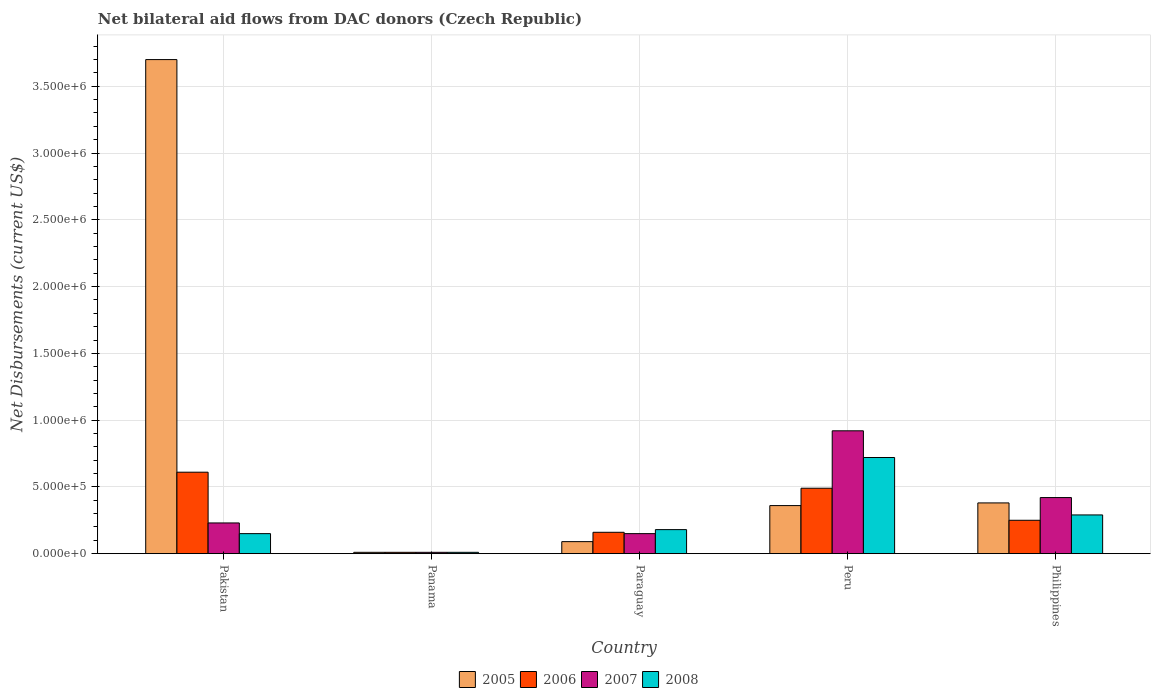Are the number of bars per tick equal to the number of legend labels?
Your answer should be very brief. Yes. How many bars are there on the 4th tick from the right?
Give a very brief answer. 4. What is the label of the 3rd group of bars from the left?
Your answer should be compact. Paraguay. In how many cases, is the number of bars for a given country not equal to the number of legend labels?
Provide a succinct answer. 0. Across all countries, what is the minimum net bilateral aid flows in 2008?
Provide a short and direct response. 10000. In which country was the net bilateral aid flows in 2007 minimum?
Your answer should be very brief. Panama. What is the total net bilateral aid flows in 2006 in the graph?
Give a very brief answer. 1.52e+06. What is the difference between the net bilateral aid flows in 2005 in Pakistan and that in Peru?
Keep it short and to the point. 3.34e+06. What is the difference between the net bilateral aid flows in 2006 in Philippines and the net bilateral aid flows in 2005 in Pakistan?
Make the answer very short. -3.45e+06. What is the average net bilateral aid flows in 2006 per country?
Your answer should be compact. 3.04e+05. What is the difference between the net bilateral aid flows of/in 2008 and net bilateral aid flows of/in 2006 in Pakistan?
Keep it short and to the point. -4.60e+05. In how many countries, is the net bilateral aid flows in 2006 greater than 1700000 US$?
Your answer should be compact. 0. What is the ratio of the net bilateral aid flows in 2006 in Panama to that in Philippines?
Keep it short and to the point. 0.04. What is the difference between the highest and the second highest net bilateral aid flows in 2007?
Give a very brief answer. 6.90e+05. What is the difference between the highest and the lowest net bilateral aid flows in 2007?
Offer a very short reply. 9.10e+05. Is the sum of the net bilateral aid flows in 2006 in Pakistan and Philippines greater than the maximum net bilateral aid flows in 2007 across all countries?
Keep it short and to the point. No. Is it the case that in every country, the sum of the net bilateral aid flows in 2006 and net bilateral aid flows in 2008 is greater than the sum of net bilateral aid flows in 2005 and net bilateral aid flows in 2007?
Provide a short and direct response. No. What does the 3rd bar from the left in Paraguay represents?
Provide a short and direct response. 2007. How many bars are there?
Give a very brief answer. 20. Are all the bars in the graph horizontal?
Give a very brief answer. No. Are the values on the major ticks of Y-axis written in scientific E-notation?
Your answer should be very brief. Yes. How many legend labels are there?
Your answer should be very brief. 4. How are the legend labels stacked?
Give a very brief answer. Horizontal. What is the title of the graph?
Provide a succinct answer. Net bilateral aid flows from DAC donors (Czech Republic). Does "1980" appear as one of the legend labels in the graph?
Offer a very short reply. No. What is the label or title of the X-axis?
Offer a terse response. Country. What is the label or title of the Y-axis?
Your answer should be compact. Net Disbursements (current US$). What is the Net Disbursements (current US$) of 2005 in Pakistan?
Give a very brief answer. 3.70e+06. What is the Net Disbursements (current US$) in 2005 in Panama?
Ensure brevity in your answer.  10000. What is the Net Disbursements (current US$) in 2006 in Panama?
Your answer should be compact. 10000. What is the Net Disbursements (current US$) in 2007 in Panama?
Give a very brief answer. 10000. What is the Net Disbursements (current US$) of 2005 in Paraguay?
Ensure brevity in your answer.  9.00e+04. What is the Net Disbursements (current US$) in 2007 in Paraguay?
Your response must be concise. 1.50e+05. What is the Net Disbursements (current US$) in 2005 in Peru?
Ensure brevity in your answer.  3.60e+05. What is the Net Disbursements (current US$) in 2006 in Peru?
Keep it short and to the point. 4.90e+05. What is the Net Disbursements (current US$) of 2007 in Peru?
Provide a succinct answer. 9.20e+05. What is the Net Disbursements (current US$) in 2008 in Peru?
Offer a terse response. 7.20e+05. What is the Net Disbursements (current US$) of 2005 in Philippines?
Offer a terse response. 3.80e+05. What is the Net Disbursements (current US$) of 2007 in Philippines?
Ensure brevity in your answer.  4.20e+05. Across all countries, what is the maximum Net Disbursements (current US$) in 2005?
Your response must be concise. 3.70e+06. Across all countries, what is the maximum Net Disbursements (current US$) of 2006?
Make the answer very short. 6.10e+05. Across all countries, what is the maximum Net Disbursements (current US$) in 2007?
Your answer should be compact. 9.20e+05. Across all countries, what is the maximum Net Disbursements (current US$) of 2008?
Your answer should be compact. 7.20e+05. What is the total Net Disbursements (current US$) of 2005 in the graph?
Offer a very short reply. 4.54e+06. What is the total Net Disbursements (current US$) in 2006 in the graph?
Provide a succinct answer. 1.52e+06. What is the total Net Disbursements (current US$) in 2007 in the graph?
Your answer should be compact. 1.73e+06. What is the total Net Disbursements (current US$) in 2008 in the graph?
Give a very brief answer. 1.35e+06. What is the difference between the Net Disbursements (current US$) of 2005 in Pakistan and that in Panama?
Your response must be concise. 3.69e+06. What is the difference between the Net Disbursements (current US$) in 2007 in Pakistan and that in Panama?
Your answer should be compact. 2.20e+05. What is the difference between the Net Disbursements (current US$) in 2008 in Pakistan and that in Panama?
Provide a succinct answer. 1.40e+05. What is the difference between the Net Disbursements (current US$) of 2005 in Pakistan and that in Paraguay?
Keep it short and to the point. 3.61e+06. What is the difference between the Net Disbursements (current US$) in 2006 in Pakistan and that in Paraguay?
Make the answer very short. 4.50e+05. What is the difference between the Net Disbursements (current US$) of 2008 in Pakistan and that in Paraguay?
Give a very brief answer. -3.00e+04. What is the difference between the Net Disbursements (current US$) in 2005 in Pakistan and that in Peru?
Offer a terse response. 3.34e+06. What is the difference between the Net Disbursements (current US$) in 2006 in Pakistan and that in Peru?
Your response must be concise. 1.20e+05. What is the difference between the Net Disbursements (current US$) in 2007 in Pakistan and that in Peru?
Your answer should be very brief. -6.90e+05. What is the difference between the Net Disbursements (current US$) of 2008 in Pakistan and that in Peru?
Offer a very short reply. -5.70e+05. What is the difference between the Net Disbursements (current US$) in 2005 in Pakistan and that in Philippines?
Provide a short and direct response. 3.32e+06. What is the difference between the Net Disbursements (current US$) of 2006 in Pakistan and that in Philippines?
Provide a succinct answer. 3.60e+05. What is the difference between the Net Disbursements (current US$) in 2007 in Pakistan and that in Philippines?
Your answer should be very brief. -1.90e+05. What is the difference between the Net Disbursements (current US$) of 2008 in Pakistan and that in Philippines?
Your answer should be very brief. -1.40e+05. What is the difference between the Net Disbursements (current US$) in 2005 in Panama and that in Paraguay?
Your answer should be very brief. -8.00e+04. What is the difference between the Net Disbursements (current US$) in 2006 in Panama and that in Paraguay?
Keep it short and to the point. -1.50e+05. What is the difference between the Net Disbursements (current US$) in 2005 in Panama and that in Peru?
Provide a short and direct response. -3.50e+05. What is the difference between the Net Disbursements (current US$) in 2006 in Panama and that in Peru?
Keep it short and to the point. -4.80e+05. What is the difference between the Net Disbursements (current US$) of 2007 in Panama and that in Peru?
Ensure brevity in your answer.  -9.10e+05. What is the difference between the Net Disbursements (current US$) in 2008 in Panama and that in Peru?
Offer a terse response. -7.10e+05. What is the difference between the Net Disbursements (current US$) in 2005 in Panama and that in Philippines?
Offer a terse response. -3.70e+05. What is the difference between the Net Disbursements (current US$) in 2007 in Panama and that in Philippines?
Offer a terse response. -4.10e+05. What is the difference between the Net Disbursements (current US$) in 2008 in Panama and that in Philippines?
Ensure brevity in your answer.  -2.80e+05. What is the difference between the Net Disbursements (current US$) of 2006 in Paraguay and that in Peru?
Provide a short and direct response. -3.30e+05. What is the difference between the Net Disbursements (current US$) in 2007 in Paraguay and that in Peru?
Your answer should be very brief. -7.70e+05. What is the difference between the Net Disbursements (current US$) in 2008 in Paraguay and that in Peru?
Provide a succinct answer. -5.40e+05. What is the difference between the Net Disbursements (current US$) of 2006 in Paraguay and that in Philippines?
Offer a terse response. -9.00e+04. What is the difference between the Net Disbursements (current US$) of 2007 in Paraguay and that in Philippines?
Ensure brevity in your answer.  -2.70e+05. What is the difference between the Net Disbursements (current US$) of 2006 in Peru and that in Philippines?
Offer a very short reply. 2.40e+05. What is the difference between the Net Disbursements (current US$) in 2005 in Pakistan and the Net Disbursements (current US$) in 2006 in Panama?
Your answer should be very brief. 3.69e+06. What is the difference between the Net Disbursements (current US$) in 2005 in Pakistan and the Net Disbursements (current US$) in 2007 in Panama?
Offer a terse response. 3.69e+06. What is the difference between the Net Disbursements (current US$) in 2005 in Pakistan and the Net Disbursements (current US$) in 2008 in Panama?
Keep it short and to the point. 3.69e+06. What is the difference between the Net Disbursements (current US$) in 2006 in Pakistan and the Net Disbursements (current US$) in 2007 in Panama?
Keep it short and to the point. 6.00e+05. What is the difference between the Net Disbursements (current US$) of 2006 in Pakistan and the Net Disbursements (current US$) of 2008 in Panama?
Provide a short and direct response. 6.00e+05. What is the difference between the Net Disbursements (current US$) in 2007 in Pakistan and the Net Disbursements (current US$) in 2008 in Panama?
Keep it short and to the point. 2.20e+05. What is the difference between the Net Disbursements (current US$) of 2005 in Pakistan and the Net Disbursements (current US$) of 2006 in Paraguay?
Make the answer very short. 3.54e+06. What is the difference between the Net Disbursements (current US$) of 2005 in Pakistan and the Net Disbursements (current US$) of 2007 in Paraguay?
Provide a succinct answer. 3.55e+06. What is the difference between the Net Disbursements (current US$) in 2005 in Pakistan and the Net Disbursements (current US$) in 2008 in Paraguay?
Provide a short and direct response. 3.52e+06. What is the difference between the Net Disbursements (current US$) of 2006 in Pakistan and the Net Disbursements (current US$) of 2007 in Paraguay?
Ensure brevity in your answer.  4.60e+05. What is the difference between the Net Disbursements (current US$) of 2006 in Pakistan and the Net Disbursements (current US$) of 2008 in Paraguay?
Make the answer very short. 4.30e+05. What is the difference between the Net Disbursements (current US$) in 2007 in Pakistan and the Net Disbursements (current US$) in 2008 in Paraguay?
Your answer should be very brief. 5.00e+04. What is the difference between the Net Disbursements (current US$) of 2005 in Pakistan and the Net Disbursements (current US$) of 2006 in Peru?
Make the answer very short. 3.21e+06. What is the difference between the Net Disbursements (current US$) of 2005 in Pakistan and the Net Disbursements (current US$) of 2007 in Peru?
Your answer should be compact. 2.78e+06. What is the difference between the Net Disbursements (current US$) of 2005 in Pakistan and the Net Disbursements (current US$) of 2008 in Peru?
Give a very brief answer. 2.98e+06. What is the difference between the Net Disbursements (current US$) in 2006 in Pakistan and the Net Disbursements (current US$) in 2007 in Peru?
Your answer should be compact. -3.10e+05. What is the difference between the Net Disbursements (current US$) in 2007 in Pakistan and the Net Disbursements (current US$) in 2008 in Peru?
Your response must be concise. -4.90e+05. What is the difference between the Net Disbursements (current US$) in 2005 in Pakistan and the Net Disbursements (current US$) in 2006 in Philippines?
Give a very brief answer. 3.45e+06. What is the difference between the Net Disbursements (current US$) in 2005 in Pakistan and the Net Disbursements (current US$) in 2007 in Philippines?
Offer a very short reply. 3.28e+06. What is the difference between the Net Disbursements (current US$) of 2005 in Pakistan and the Net Disbursements (current US$) of 2008 in Philippines?
Ensure brevity in your answer.  3.41e+06. What is the difference between the Net Disbursements (current US$) in 2006 in Pakistan and the Net Disbursements (current US$) in 2007 in Philippines?
Provide a short and direct response. 1.90e+05. What is the difference between the Net Disbursements (current US$) of 2006 in Pakistan and the Net Disbursements (current US$) of 2008 in Philippines?
Provide a short and direct response. 3.20e+05. What is the difference between the Net Disbursements (current US$) of 2007 in Pakistan and the Net Disbursements (current US$) of 2008 in Philippines?
Your answer should be very brief. -6.00e+04. What is the difference between the Net Disbursements (current US$) in 2006 in Panama and the Net Disbursements (current US$) in 2007 in Paraguay?
Your answer should be compact. -1.40e+05. What is the difference between the Net Disbursements (current US$) of 2007 in Panama and the Net Disbursements (current US$) of 2008 in Paraguay?
Ensure brevity in your answer.  -1.70e+05. What is the difference between the Net Disbursements (current US$) in 2005 in Panama and the Net Disbursements (current US$) in 2006 in Peru?
Offer a very short reply. -4.80e+05. What is the difference between the Net Disbursements (current US$) of 2005 in Panama and the Net Disbursements (current US$) of 2007 in Peru?
Keep it short and to the point. -9.10e+05. What is the difference between the Net Disbursements (current US$) of 2005 in Panama and the Net Disbursements (current US$) of 2008 in Peru?
Your answer should be compact. -7.10e+05. What is the difference between the Net Disbursements (current US$) of 2006 in Panama and the Net Disbursements (current US$) of 2007 in Peru?
Keep it short and to the point. -9.10e+05. What is the difference between the Net Disbursements (current US$) of 2006 in Panama and the Net Disbursements (current US$) of 2008 in Peru?
Your response must be concise. -7.10e+05. What is the difference between the Net Disbursements (current US$) of 2007 in Panama and the Net Disbursements (current US$) of 2008 in Peru?
Your response must be concise. -7.10e+05. What is the difference between the Net Disbursements (current US$) in 2005 in Panama and the Net Disbursements (current US$) in 2006 in Philippines?
Keep it short and to the point. -2.40e+05. What is the difference between the Net Disbursements (current US$) in 2005 in Panama and the Net Disbursements (current US$) in 2007 in Philippines?
Your answer should be compact. -4.10e+05. What is the difference between the Net Disbursements (current US$) of 2005 in Panama and the Net Disbursements (current US$) of 2008 in Philippines?
Your answer should be very brief. -2.80e+05. What is the difference between the Net Disbursements (current US$) of 2006 in Panama and the Net Disbursements (current US$) of 2007 in Philippines?
Your response must be concise. -4.10e+05. What is the difference between the Net Disbursements (current US$) of 2006 in Panama and the Net Disbursements (current US$) of 2008 in Philippines?
Your answer should be very brief. -2.80e+05. What is the difference between the Net Disbursements (current US$) in 2007 in Panama and the Net Disbursements (current US$) in 2008 in Philippines?
Your response must be concise. -2.80e+05. What is the difference between the Net Disbursements (current US$) in 2005 in Paraguay and the Net Disbursements (current US$) in 2006 in Peru?
Keep it short and to the point. -4.00e+05. What is the difference between the Net Disbursements (current US$) of 2005 in Paraguay and the Net Disbursements (current US$) of 2007 in Peru?
Keep it short and to the point. -8.30e+05. What is the difference between the Net Disbursements (current US$) of 2005 in Paraguay and the Net Disbursements (current US$) of 2008 in Peru?
Ensure brevity in your answer.  -6.30e+05. What is the difference between the Net Disbursements (current US$) in 2006 in Paraguay and the Net Disbursements (current US$) in 2007 in Peru?
Keep it short and to the point. -7.60e+05. What is the difference between the Net Disbursements (current US$) of 2006 in Paraguay and the Net Disbursements (current US$) of 2008 in Peru?
Your answer should be very brief. -5.60e+05. What is the difference between the Net Disbursements (current US$) of 2007 in Paraguay and the Net Disbursements (current US$) of 2008 in Peru?
Provide a succinct answer. -5.70e+05. What is the difference between the Net Disbursements (current US$) in 2005 in Paraguay and the Net Disbursements (current US$) in 2007 in Philippines?
Give a very brief answer. -3.30e+05. What is the difference between the Net Disbursements (current US$) in 2006 in Paraguay and the Net Disbursements (current US$) in 2007 in Philippines?
Offer a very short reply. -2.60e+05. What is the difference between the Net Disbursements (current US$) in 2007 in Paraguay and the Net Disbursements (current US$) in 2008 in Philippines?
Your response must be concise. -1.40e+05. What is the difference between the Net Disbursements (current US$) of 2007 in Peru and the Net Disbursements (current US$) of 2008 in Philippines?
Keep it short and to the point. 6.30e+05. What is the average Net Disbursements (current US$) of 2005 per country?
Provide a succinct answer. 9.08e+05. What is the average Net Disbursements (current US$) of 2006 per country?
Provide a succinct answer. 3.04e+05. What is the average Net Disbursements (current US$) in 2007 per country?
Give a very brief answer. 3.46e+05. What is the difference between the Net Disbursements (current US$) of 2005 and Net Disbursements (current US$) of 2006 in Pakistan?
Offer a terse response. 3.09e+06. What is the difference between the Net Disbursements (current US$) in 2005 and Net Disbursements (current US$) in 2007 in Pakistan?
Offer a terse response. 3.47e+06. What is the difference between the Net Disbursements (current US$) of 2005 and Net Disbursements (current US$) of 2008 in Pakistan?
Ensure brevity in your answer.  3.55e+06. What is the difference between the Net Disbursements (current US$) in 2007 and Net Disbursements (current US$) in 2008 in Pakistan?
Offer a terse response. 8.00e+04. What is the difference between the Net Disbursements (current US$) in 2005 and Net Disbursements (current US$) in 2007 in Panama?
Give a very brief answer. 0. What is the difference between the Net Disbursements (current US$) in 2005 and Net Disbursements (current US$) in 2008 in Panama?
Ensure brevity in your answer.  0. What is the difference between the Net Disbursements (current US$) of 2005 and Net Disbursements (current US$) of 2007 in Paraguay?
Your response must be concise. -6.00e+04. What is the difference between the Net Disbursements (current US$) in 2007 and Net Disbursements (current US$) in 2008 in Paraguay?
Your answer should be compact. -3.00e+04. What is the difference between the Net Disbursements (current US$) in 2005 and Net Disbursements (current US$) in 2007 in Peru?
Provide a short and direct response. -5.60e+05. What is the difference between the Net Disbursements (current US$) of 2005 and Net Disbursements (current US$) of 2008 in Peru?
Your response must be concise. -3.60e+05. What is the difference between the Net Disbursements (current US$) of 2006 and Net Disbursements (current US$) of 2007 in Peru?
Make the answer very short. -4.30e+05. What is the difference between the Net Disbursements (current US$) in 2006 and Net Disbursements (current US$) in 2008 in Peru?
Make the answer very short. -2.30e+05. What is the difference between the Net Disbursements (current US$) in 2005 and Net Disbursements (current US$) in 2006 in Philippines?
Your answer should be very brief. 1.30e+05. What is the difference between the Net Disbursements (current US$) in 2006 and Net Disbursements (current US$) in 2007 in Philippines?
Make the answer very short. -1.70e+05. What is the difference between the Net Disbursements (current US$) of 2007 and Net Disbursements (current US$) of 2008 in Philippines?
Provide a short and direct response. 1.30e+05. What is the ratio of the Net Disbursements (current US$) in 2005 in Pakistan to that in Panama?
Offer a very short reply. 370. What is the ratio of the Net Disbursements (current US$) in 2006 in Pakistan to that in Panama?
Your response must be concise. 61. What is the ratio of the Net Disbursements (current US$) in 2007 in Pakistan to that in Panama?
Provide a short and direct response. 23. What is the ratio of the Net Disbursements (current US$) of 2008 in Pakistan to that in Panama?
Keep it short and to the point. 15. What is the ratio of the Net Disbursements (current US$) of 2005 in Pakistan to that in Paraguay?
Your response must be concise. 41.11. What is the ratio of the Net Disbursements (current US$) of 2006 in Pakistan to that in Paraguay?
Give a very brief answer. 3.81. What is the ratio of the Net Disbursements (current US$) in 2007 in Pakistan to that in Paraguay?
Your answer should be compact. 1.53. What is the ratio of the Net Disbursements (current US$) in 2005 in Pakistan to that in Peru?
Provide a succinct answer. 10.28. What is the ratio of the Net Disbursements (current US$) of 2006 in Pakistan to that in Peru?
Your answer should be compact. 1.24. What is the ratio of the Net Disbursements (current US$) in 2007 in Pakistan to that in Peru?
Your answer should be compact. 0.25. What is the ratio of the Net Disbursements (current US$) in 2008 in Pakistan to that in Peru?
Your answer should be very brief. 0.21. What is the ratio of the Net Disbursements (current US$) of 2005 in Pakistan to that in Philippines?
Give a very brief answer. 9.74. What is the ratio of the Net Disbursements (current US$) of 2006 in Pakistan to that in Philippines?
Offer a very short reply. 2.44. What is the ratio of the Net Disbursements (current US$) in 2007 in Pakistan to that in Philippines?
Make the answer very short. 0.55. What is the ratio of the Net Disbursements (current US$) of 2008 in Pakistan to that in Philippines?
Provide a succinct answer. 0.52. What is the ratio of the Net Disbursements (current US$) of 2005 in Panama to that in Paraguay?
Your answer should be very brief. 0.11. What is the ratio of the Net Disbursements (current US$) of 2006 in Panama to that in Paraguay?
Your answer should be very brief. 0.06. What is the ratio of the Net Disbursements (current US$) in 2007 in Panama to that in Paraguay?
Keep it short and to the point. 0.07. What is the ratio of the Net Disbursements (current US$) of 2008 in Panama to that in Paraguay?
Give a very brief answer. 0.06. What is the ratio of the Net Disbursements (current US$) in 2005 in Panama to that in Peru?
Make the answer very short. 0.03. What is the ratio of the Net Disbursements (current US$) in 2006 in Panama to that in Peru?
Offer a very short reply. 0.02. What is the ratio of the Net Disbursements (current US$) of 2007 in Panama to that in Peru?
Offer a terse response. 0.01. What is the ratio of the Net Disbursements (current US$) in 2008 in Panama to that in Peru?
Your response must be concise. 0.01. What is the ratio of the Net Disbursements (current US$) of 2005 in Panama to that in Philippines?
Your answer should be compact. 0.03. What is the ratio of the Net Disbursements (current US$) of 2007 in Panama to that in Philippines?
Give a very brief answer. 0.02. What is the ratio of the Net Disbursements (current US$) in 2008 in Panama to that in Philippines?
Your answer should be very brief. 0.03. What is the ratio of the Net Disbursements (current US$) in 2006 in Paraguay to that in Peru?
Keep it short and to the point. 0.33. What is the ratio of the Net Disbursements (current US$) in 2007 in Paraguay to that in Peru?
Give a very brief answer. 0.16. What is the ratio of the Net Disbursements (current US$) in 2008 in Paraguay to that in Peru?
Give a very brief answer. 0.25. What is the ratio of the Net Disbursements (current US$) in 2005 in Paraguay to that in Philippines?
Give a very brief answer. 0.24. What is the ratio of the Net Disbursements (current US$) in 2006 in Paraguay to that in Philippines?
Offer a very short reply. 0.64. What is the ratio of the Net Disbursements (current US$) in 2007 in Paraguay to that in Philippines?
Your answer should be very brief. 0.36. What is the ratio of the Net Disbursements (current US$) of 2008 in Paraguay to that in Philippines?
Keep it short and to the point. 0.62. What is the ratio of the Net Disbursements (current US$) in 2006 in Peru to that in Philippines?
Provide a short and direct response. 1.96. What is the ratio of the Net Disbursements (current US$) in 2007 in Peru to that in Philippines?
Your response must be concise. 2.19. What is the ratio of the Net Disbursements (current US$) of 2008 in Peru to that in Philippines?
Your response must be concise. 2.48. What is the difference between the highest and the second highest Net Disbursements (current US$) of 2005?
Offer a very short reply. 3.32e+06. What is the difference between the highest and the second highest Net Disbursements (current US$) in 2007?
Ensure brevity in your answer.  5.00e+05. What is the difference between the highest and the lowest Net Disbursements (current US$) of 2005?
Offer a terse response. 3.69e+06. What is the difference between the highest and the lowest Net Disbursements (current US$) of 2006?
Give a very brief answer. 6.00e+05. What is the difference between the highest and the lowest Net Disbursements (current US$) of 2007?
Keep it short and to the point. 9.10e+05. What is the difference between the highest and the lowest Net Disbursements (current US$) of 2008?
Offer a very short reply. 7.10e+05. 